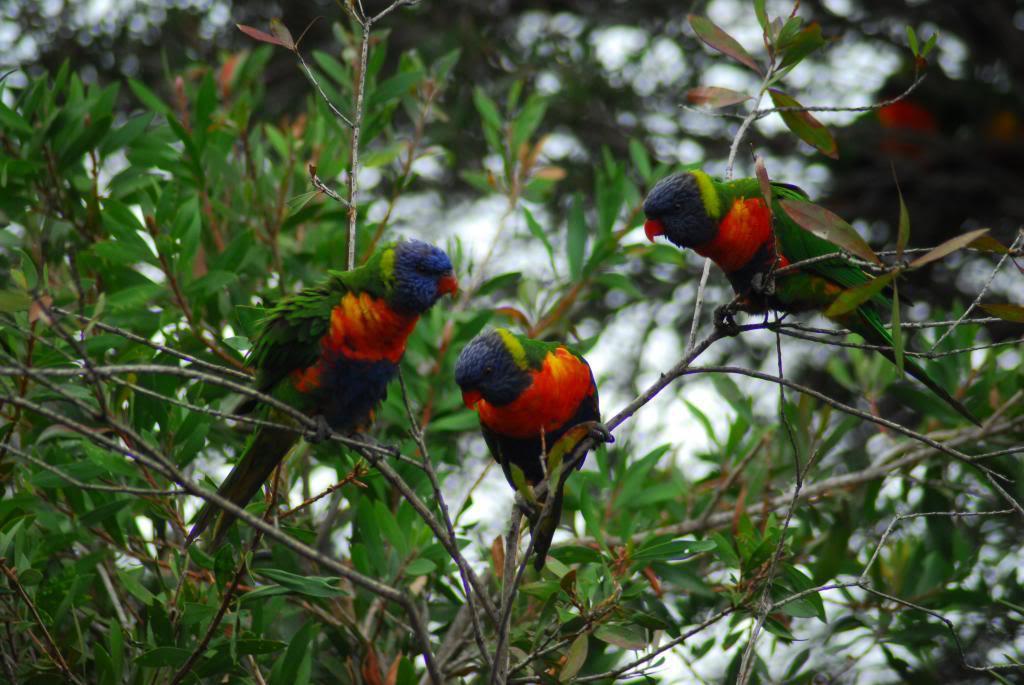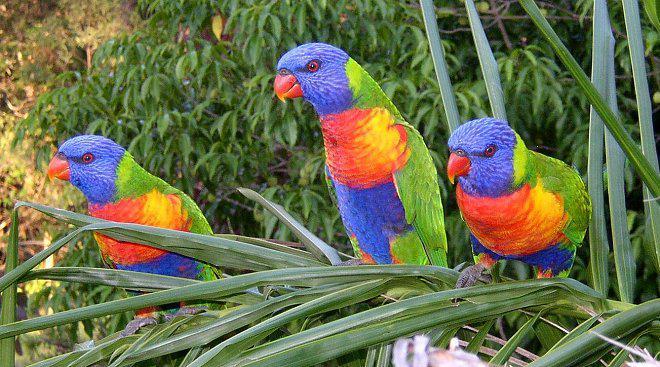The first image is the image on the left, the second image is the image on the right. Evaluate the accuracy of this statement regarding the images: "The image on the right contains two parrots.". Is it true? Answer yes or no. No. The first image is the image on the left, the second image is the image on the right. Evaluate the accuracy of this statement regarding the images: "Both pictures have an identical number of parrots perched on branches in the foreground.". Is it true? Answer yes or no. Yes. 